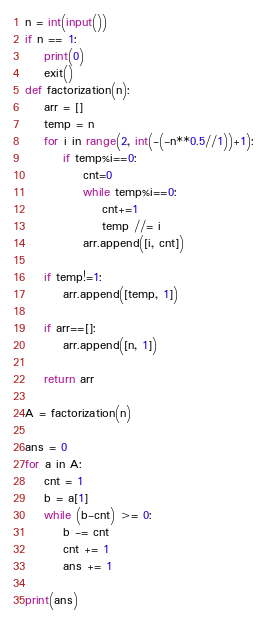<code> <loc_0><loc_0><loc_500><loc_500><_Python_>n = int(input())
if n == 1:
    print(0)
    exit()
def factorization(n):
    arr = []
    temp = n
    for i in range(2, int(-(-n**0.5//1))+1):
        if temp%i==0:
            cnt=0
            while temp%i==0:
                cnt+=1
                temp //= i
            arr.append([i, cnt])

    if temp!=1:
        arr.append([temp, 1])

    if arr==[]:
        arr.append([n, 1])

    return arr

A = factorization(n)

ans = 0
for a in A:
    cnt = 1
    b = a[1]
    while (b-cnt) >= 0:
        b -= cnt
        cnt += 1
        ans += 1

print(ans)
</code> 